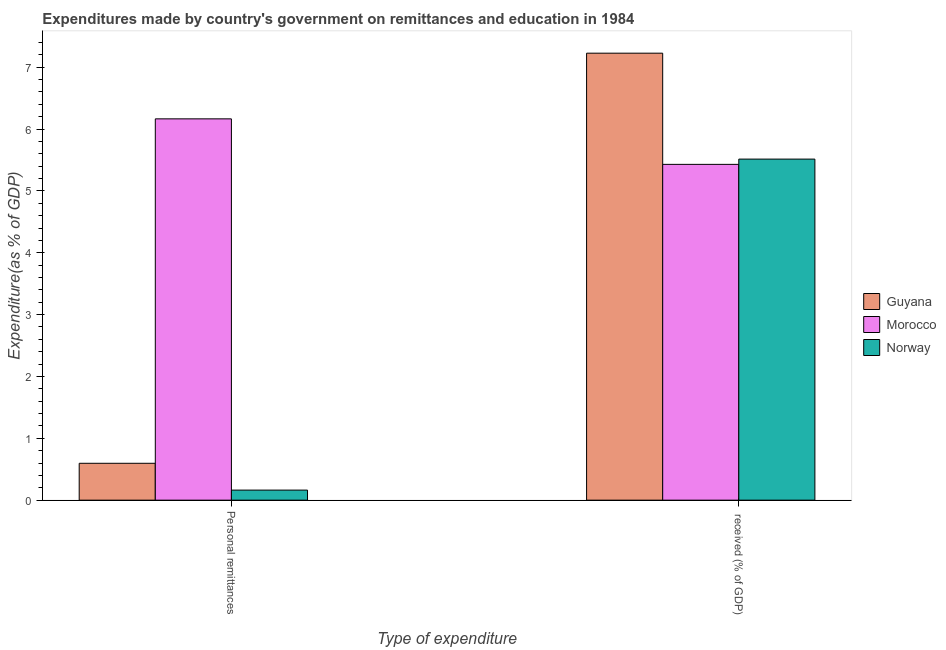How many different coloured bars are there?
Provide a succinct answer. 3. Are the number of bars on each tick of the X-axis equal?
Give a very brief answer. Yes. How many bars are there on the 1st tick from the left?
Your answer should be compact. 3. What is the label of the 1st group of bars from the left?
Make the answer very short. Personal remittances. What is the expenditure in education in Norway?
Provide a short and direct response. 5.51. Across all countries, what is the maximum expenditure in education?
Your answer should be compact. 7.23. Across all countries, what is the minimum expenditure in personal remittances?
Offer a very short reply. 0.16. In which country was the expenditure in personal remittances maximum?
Provide a succinct answer. Morocco. In which country was the expenditure in education minimum?
Ensure brevity in your answer.  Morocco. What is the total expenditure in personal remittances in the graph?
Offer a terse response. 6.92. What is the difference between the expenditure in education in Guyana and that in Norway?
Your answer should be very brief. 1.71. What is the difference between the expenditure in personal remittances in Morocco and the expenditure in education in Norway?
Give a very brief answer. 0.65. What is the average expenditure in education per country?
Make the answer very short. 6.06. What is the difference between the expenditure in personal remittances and expenditure in education in Guyana?
Keep it short and to the point. -6.63. In how many countries, is the expenditure in personal remittances greater than 6.4 %?
Provide a succinct answer. 0. What is the ratio of the expenditure in personal remittances in Guyana to that in Norway?
Make the answer very short. 3.66. In how many countries, is the expenditure in personal remittances greater than the average expenditure in personal remittances taken over all countries?
Your answer should be very brief. 1. What does the 2nd bar from the left in Personal remittances represents?
Your answer should be compact. Morocco. What does the 3rd bar from the right in Personal remittances represents?
Offer a very short reply. Guyana. How many bars are there?
Your response must be concise. 6. Are the values on the major ticks of Y-axis written in scientific E-notation?
Provide a succinct answer. No. Does the graph contain grids?
Ensure brevity in your answer.  No. Where does the legend appear in the graph?
Offer a very short reply. Center right. How are the legend labels stacked?
Your answer should be compact. Vertical. What is the title of the graph?
Your response must be concise. Expenditures made by country's government on remittances and education in 1984. Does "Central Europe" appear as one of the legend labels in the graph?
Your response must be concise. No. What is the label or title of the X-axis?
Your answer should be compact. Type of expenditure. What is the label or title of the Y-axis?
Keep it short and to the point. Expenditure(as % of GDP). What is the Expenditure(as % of GDP) in Guyana in Personal remittances?
Ensure brevity in your answer.  0.6. What is the Expenditure(as % of GDP) in Morocco in Personal remittances?
Make the answer very short. 6.17. What is the Expenditure(as % of GDP) of Norway in Personal remittances?
Ensure brevity in your answer.  0.16. What is the Expenditure(as % of GDP) in Guyana in  received (% of GDP)?
Your response must be concise. 7.23. What is the Expenditure(as % of GDP) of Morocco in  received (% of GDP)?
Your answer should be very brief. 5.43. What is the Expenditure(as % of GDP) in Norway in  received (% of GDP)?
Provide a short and direct response. 5.51. Across all Type of expenditure, what is the maximum Expenditure(as % of GDP) in Guyana?
Offer a terse response. 7.23. Across all Type of expenditure, what is the maximum Expenditure(as % of GDP) of Morocco?
Make the answer very short. 6.17. Across all Type of expenditure, what is the maximum Expenditure(as % of GDP) in Norway?
Your answer should be compact. 5.51. Across all Type of expenditure, what is the minimum Expenditure(as % of GDP) in Guyana?
Offer a very short reply. 0.6. Across all Type of expenditure, what is the minimum Expenditure(as % of GDP) of Morocco?
Provide a short and direct response. 5.43. Across all Type of expenditure, what is the minimum Expenditure(as % of GDP) of Norway?
Keep it short and to the point. 0.16. What is the total Expenditure(as % of GDP) in Guyana in the graph?
Make the answer very short. 7.82. What is the total Expenditure(as % of GDP) of Morocco in the graph?
Offer a terse response. 11.6. What is the total Expenditure(as % of GDP) in Norway in the graph?
Provide a short and direct response. 5.68. What is the difference between the Expenditure(as % of GDP) of Guyana in Personal remittances and that in  received (% of GDP)?
Keep it short and to the point. -6.63. What is the difference between the Expenditure(as % of GDP) of Morocco in Personal remittances and that in  received (% of GDP)?
Give a very brief answer. 0.74. What is the difference between the Expenditure(as % of GDP) in Norway in Personal remittances and that in  received (% of GDP)?
Give a very brief answer. -5.35. What is the difference between the Expenditure(as % of GDP) of Guyana in Personal remittances and the Expenditure(as % of GDP) of Morocco in  received (% of GDP)?
Make the answer very short. -4.83. What is the difference between the Expenditure(as % of GDP) in Guyana in Personal remittances and the Expenditure(as % of GDP) in Norway in  received (% of GDP)?
Make the answer very short. -4.92. What is the difference between the Expenditure(as % of GDP) of Morocco in Personal remittances and the Expenditure(as % of GDP) of Norway in  received (% of GDP)?
Ensure brevity in your answer.  0.65. What is the average Expenditure(as % of GDP) of Guyana per Type of expenditure?
Offer a terse response. 3.91. What is the average Expenditure(as % of GDP) in Morocco per Type of expenditure?
Provide a short and direct response. 5.8. What is the average Expenditure(as % of GDP) in Norway per Type of expenditure?
Provide a succinct answer. 2.84. What is the difference between the Expenditure(as % of GDP) of Guyana and Expenditure(as % of GDP) of Morocco in Personal remittances?
Your response must be concise. -5.57. What is the difference between the Expenditure(as % of GDP) in Guyana and Expenditure(as % of GDP) in Norway in Personal remittances?
Your answer should be very brief. 0.43. What is the difference between the Expenditure(as % of GDP) in Morocco and Expenditure(as % of GDP) in Norway in Personal remittances?
Ensure brevity in your answer.  6. What is the difference between the Expenditure(as % of GDP) in Guyana and Expenditure(as % of GDP) in Morocco in  received (% of GDP)?
Make the answer very short. 1.8. What is the difference between the Expenditure(as % of GDP) of Guyana and Expenditure(as % of GDP) of Norway in  received (% of GDP)?
Offer a very short reply. 1.71. What is the difference between the Expenditure(as % of GDP) in Morocco and Expenditure(as % of GDP) in Norway in  received (% of GDP)?
Your answer should be very brief. -0.09. What is the ratio of the Expenditure(as % of GDP) in Guyana in Personal remittances to that in  received (% of GDP)?
Your answer should be very brief. 0.08. What is the ratio of the Expenditure(as % of GDP) in Morocco in Personal remittances to that in  received (% of GDP)?
Ensure brevity in your answer.  1.14. What is the ratio of the Expenditure(as % of GDP) in Norway in Personal remittances to that in  received (% of GDP)?
Your answer should be compact. 0.03. What is the difference between the highest and the second highest Expenditure(as % of GDP) in Guyana?
Offer a terse response. 6.63. What is the difference between the highest and the second highest Expenditure(as % of GDP) of Morocco?
Make the answer very short. 0.74. What is the difference between the highest and the second highest Expenditure(as % of GDP) of Norway?
Keep it short and to the point. 5.35. What is the difference between the highest and the lowest Expenditure(as % of GDP) in Guyana?
Your answer should be very brief. 6.63. What is the difference between the highest and the lowest Expenditure(as % of GDP) of Morocco?
Your answer should be very brief. 0.74. What is the difference between the highest and the lowest Expenditure(as % of GDP) in Norway?
Offer a very short reply. 5.35. 